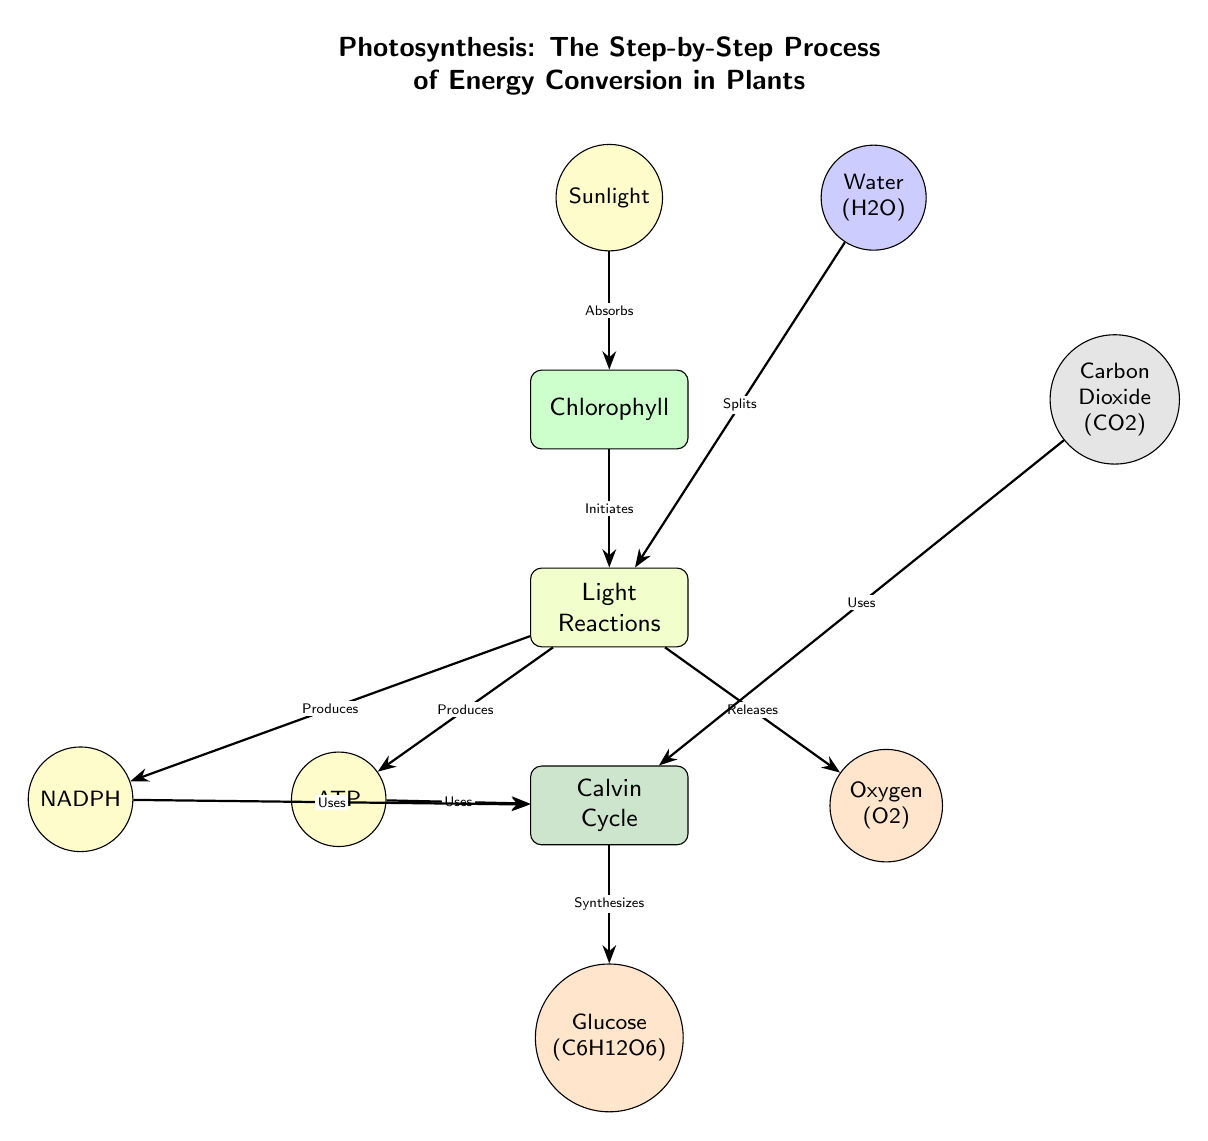What is produced during the Light Reactions? According to the diagram, ATP, NADPH, and Oxygen are produced during the Light Reactions, as indicated by the arrows leading from the Light Reactions process node.
Answer: ATP, NADPH, Oxygen What molecules are used in the Calvin Cycle? The diagram shows that Carbon Dioxide, ATP, and NADPH are used in the Calvin Cycle. Each of these molecules has an arrow pointing towards the Calvin Cycle, indicating their usage in that process.
Answer: Carbon Dioxide, ATP, NADPH How many main processes are depicted in the diagram? The diagram illustrates three main processes: Light Reactions, Calvin Cycle, and Chlorophyll. By counting these distinct process nodes, we can determine that there are three main processes involved in photosynthesis shown in the diagram.
Answer: 3 Which molecule is produced at the end of the photosynthesis process? The final outcome of the process, as shown in the diagram, is Glucose, which is produced by the Calvin Cycle. The arrow coming from the Calvin Cycle points to the Glucose node, indicating it is synthesized at this stage.
Answer: Glucose What does sunlight do in the photosynthesis process? The diagram indicates that sunlight is absorbed by Chlorophyll, which initiates the Light Reactions. The arrow shows the direction of the process, confirming the role of sunlight in starting photosynthesis.
Answer: Absorbs What is the role of water in the Light Reactions? The diagram states that water splits during the Light Reactions. This data can be observed through the arrow pointing from the Water node to the Light Reactions process node, indicating its function.
Answer: Splits How is oxygen released in the photosynthesis process? According to the diagram, Oxygen is released as a byproduct of the Light Reactions. An arrow leads from the Light Reactions process node to the Oxygen node, illustrating this flow clearly.
Answer: Released Which component helps absorb sunlight? The diagram identifies Chlorophyll as the component that absorbs sunlight. It is shown as a process node that interacts with the Sunlight node, confirming its function in this phase of photosynthesis.
Answer: Chlorophyll 